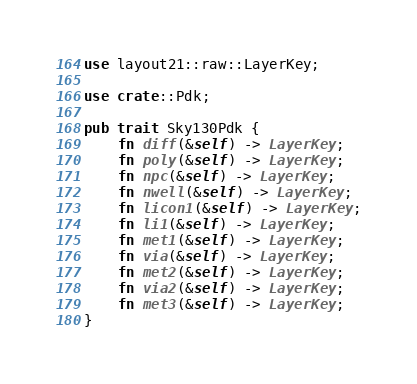<code> <loc_0><loc_0><loc_500><loc_500><_Rust_>use layout21::raw::LayerKey;

use crate::Pdk;

pub trait Sky130Pdk {
    fn diff(&self) -> LayerKey;
    fn poly(&self) -> LayerKey;
    fn npc(&self) -> LayerKey;
    fn nwell(&self) -> LayerKey;
    fn licon1(&self) -> LayerKey;
    fn li1(&self) -> LayerKey;
    fn met1(&self) -> LayerKey;
    fn via(&self) -> LayerKey;
    fn met2(&self) -> LayerKey;
    fn via2(&self) -> LayerKey;
    fn met3(&self) -> LayerKey;
}
</code> 